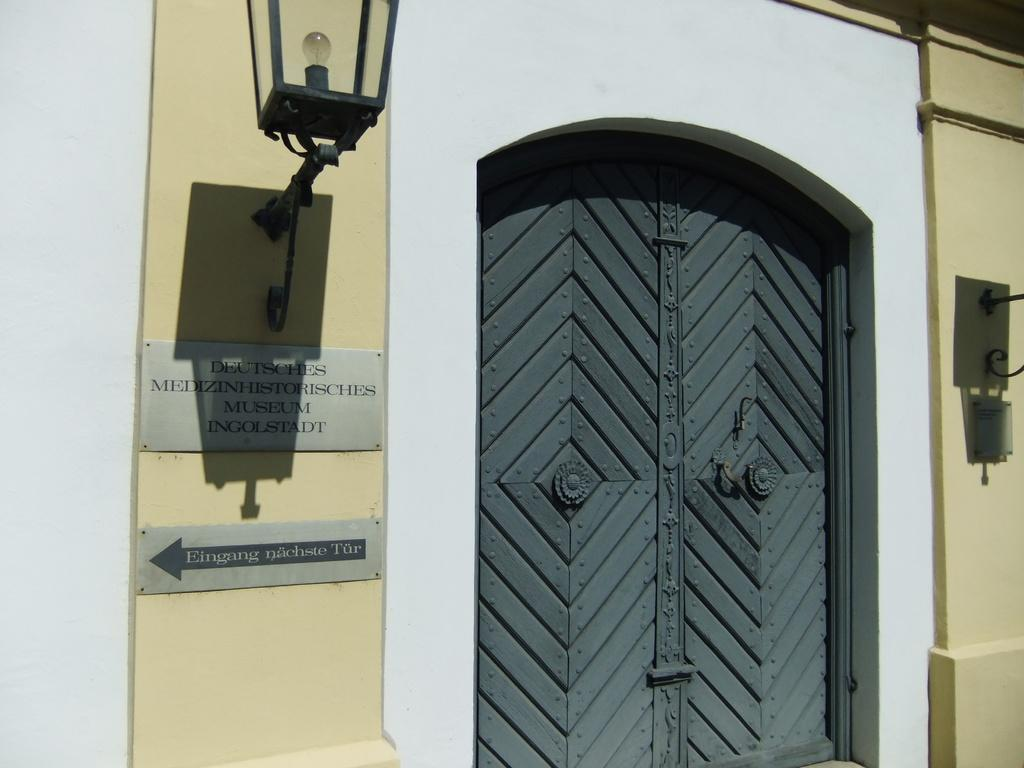What is one of the main features of the image? There is a door in the image. Can you describe any other objects in the image? There is a light attached to the wall in the image. What colors are present on the wall in the image? The wall has a yellow and white color. What type of crow can be seen sitting on the oven in the image? There is no crow or oven present in the image. 